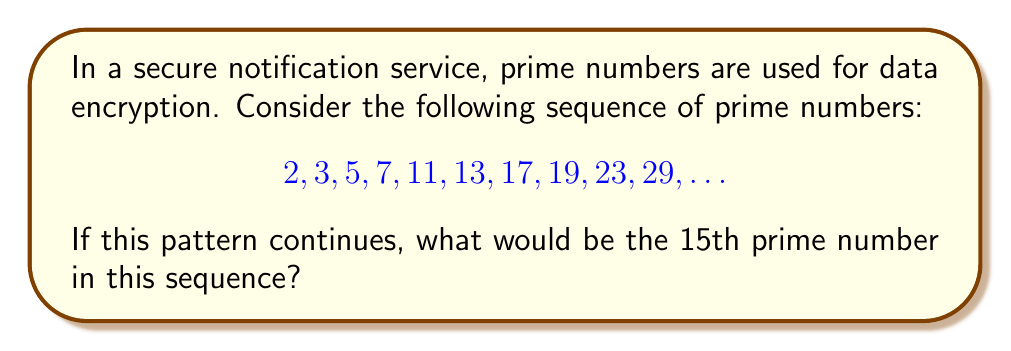What is the answer to this math problem? To find the 15th prime number in the sequence, we need to understand the pattern of prime numbers and continue it:

1. First, let's list out the given prime numbers and their positions:
   1st: 2
   2nd: 3
   3rd: 5
   4th: 7
   5th: 11
   6th: 13
   7th: 17
   8th: 19
   9th: 23
   10th: 29

2. We need to find the next 5 prime numbers to reach the 15th position.

3. To find the next prime number, we start with the last known prime (29) and check each subsequent odd number for primality:
   - 31 is prime (11th)
   - 33 is not prime (divisible by 3)
   - 37 is prime (12th)
   - 39 is not prime (divisible by 3)
   - 41 is prime (13th)
   - 43 is prime (14th)
   - 47 is prime (15th)

4. We stop at 47 as it is the 15th prime number in the sequence.

This method of finding prime numbers is known as the sieve of Eratosthenes, which is an efficient algorithm for finding all primes up to a given limit. In a real-world scenario, more optimized algorithms would be used for generating large prime numbers for encryption purposes.
Answer: 47 